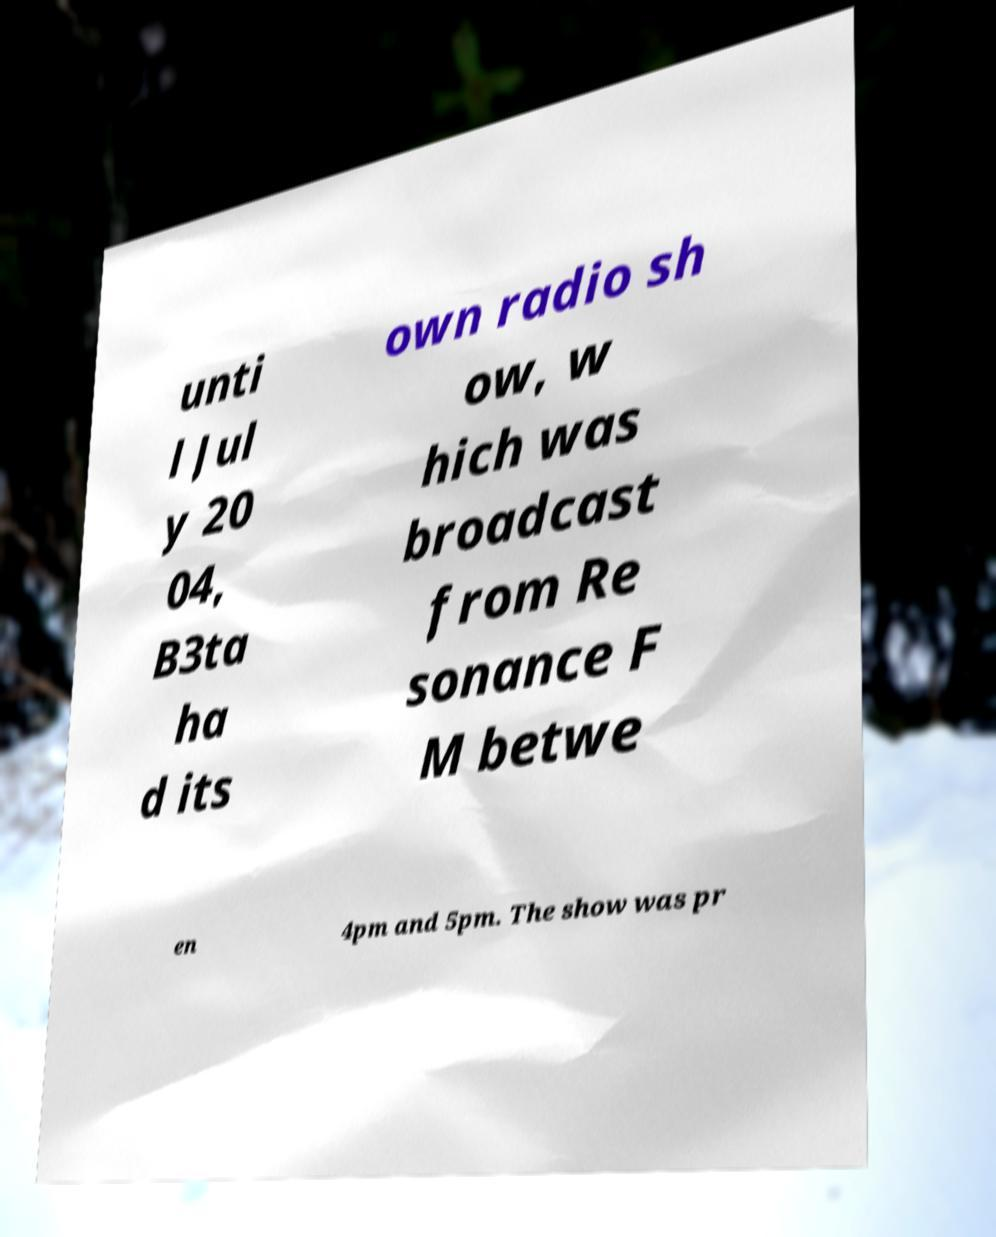Could you assist in decoding the text presented in this image and type it out clearly? unti l Jul y 20 04, B3ta ha d its own radio sh ow, w hich was broadcast from Re sonance F M betwe en 4pm and 5pm. The show was pr 